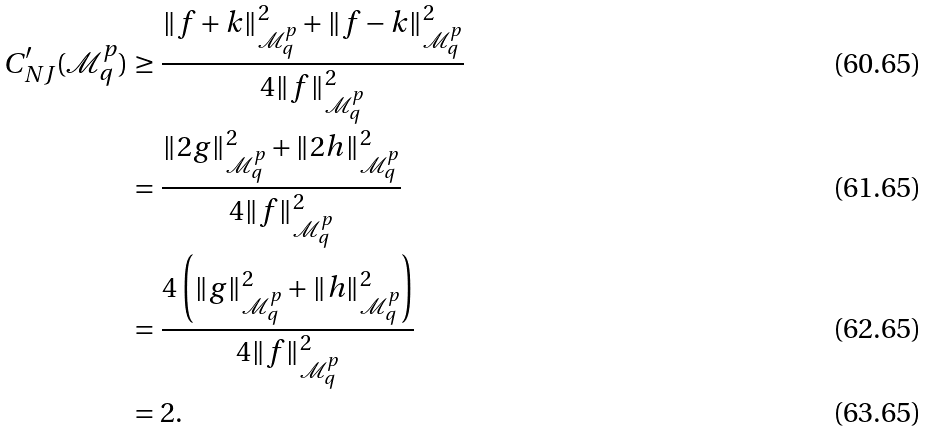Convert formula to latex. <formula><loc_0><loc_0><loc_500><loc_500>C ^ { \prime } _ { N J } ( \mathcal { M } ^ { p } _ { q } ) & \geq \frac { \| f + k \| _ { \mathcal { M } ^ { p } _ { q } } ^ { 2 } + \| f - k \| _ { \mathcal { M } ^ { p } _ { q } } ^ { 2 } } { 4 \| f \| ^ { 2 } _ { \mathcal { M } ^ { p } _ { q } } } \\ & = \frac { \| 2 g \| ^ { 2 } _ { \mathcal { M } ^ { p } _ { q } } + \| 2 h \| ^ { 2 } _ { \mathcal { M } ^ { p } _ { q } } } { 4 \| f \| ^ { 2 } _ { \mathcal { M } ^ { p } _ { q } } } \\ & = \frac { 4 \left ( \| g \| ^ { 2 } _ { \mathcal { M } ^ { p } _ { q } } + \| h \| ^ { 2 } _ { \mathcal { M } ^ { p } _ { q } } \right ) } { 4 \| f \| ^ { 2 } _ { \mathcal { M } ^ { p } _ { q } } } \\ & = 2 .</formula> 